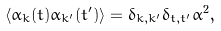<formula> <loc_0><loc_0><loc_500><loc_500>\langle \alpha _ { k } ( t ) \alpha _ { k ^ { \prime } } ( t ^ { \prime } ) \rangle = { \delta } _ { k , k ^ { \prime } } { \delta } _ { t , t ^ { \prime } } { \alpha } ^ { 2 } ,</formula> 